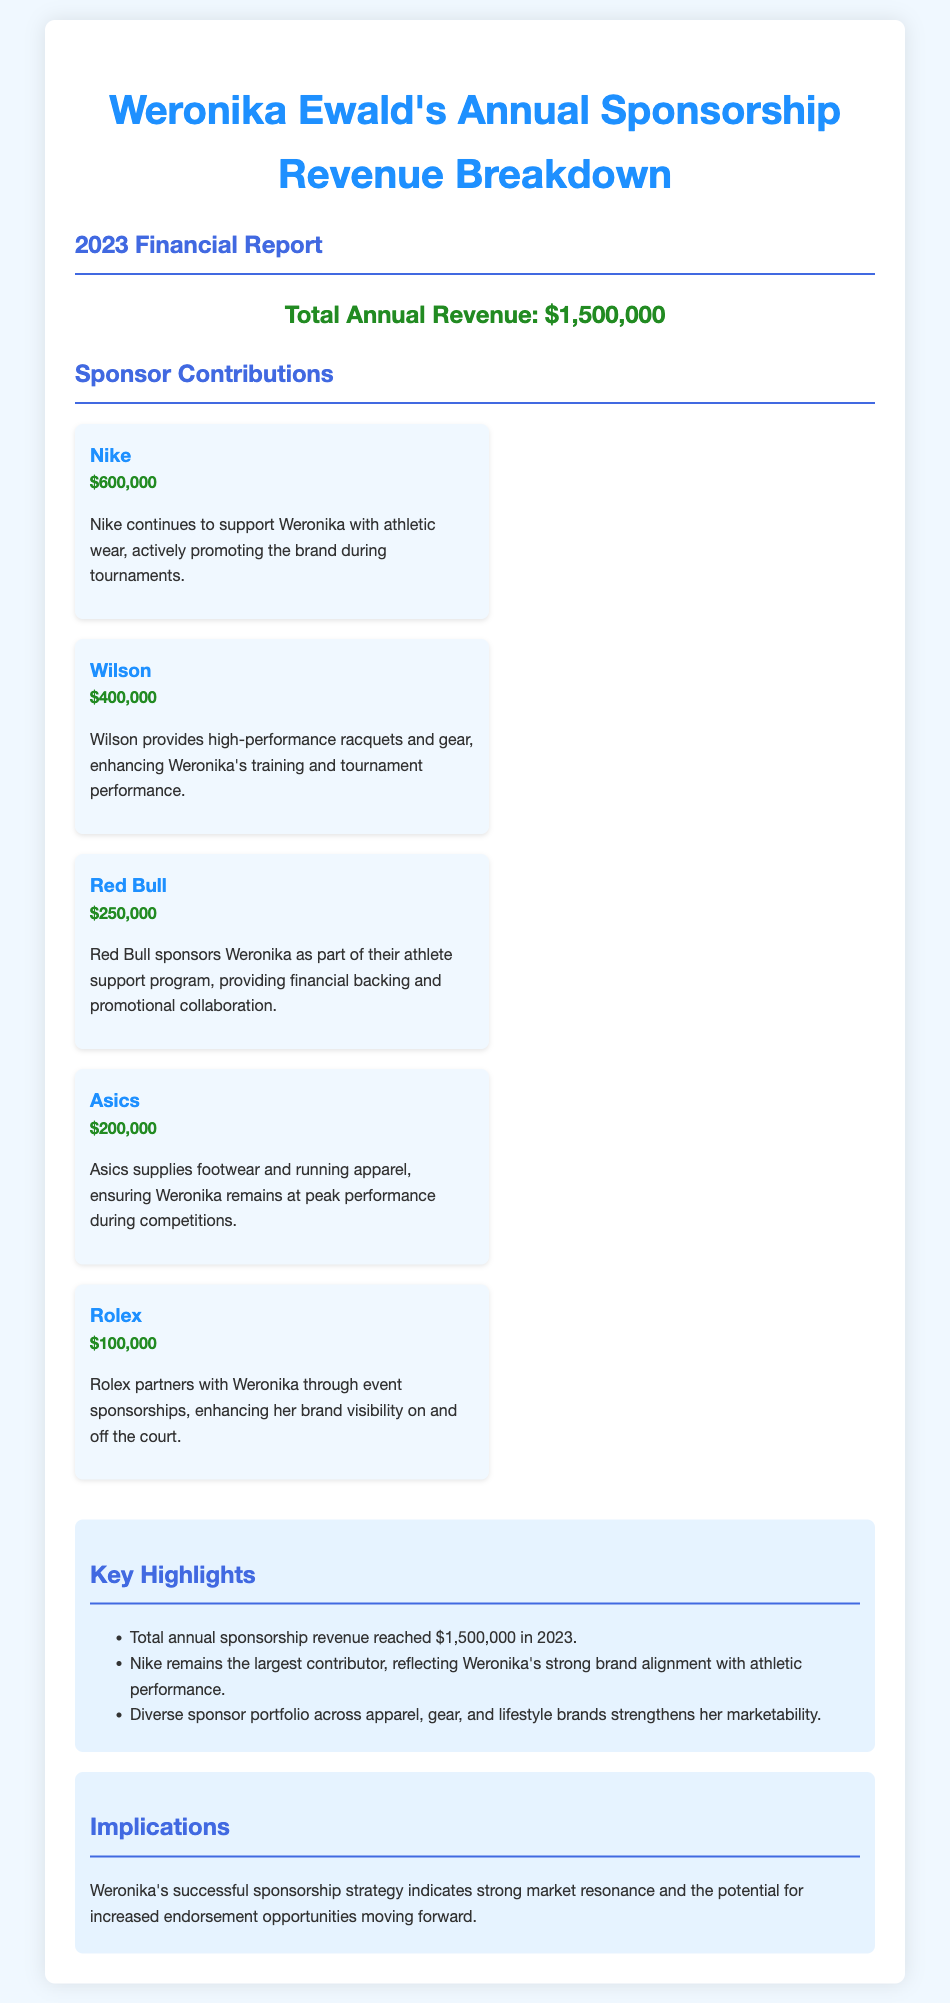What is the total annual revenue? The total annual revenue is stated in the document as $1,500,000.
Answer: $1,500,000 Who is the largest sponsor? The document highlights Nike as the largest contributor to Weronika's sponsorship revenue.
Answer: Nike How much does Wilson contribute? Wilson's contribution is specifically mentioned as $400,000 in the report.
Answer: $400,000 What type of products does Asics provide? The report indicates that Asics supplies footwear and running apparel to Weronika.
Answer: Footwear and running apparel What was the total contribution from Red Bull? The document specifies that Red Bull's sponsorship amount is $250,000.
Answer: $250,000 What key highlight is mentioned about Nike? The document states that Nike remains the largest contributor, indicating a strong brand alignment.
Answer: Largest contributor What does the sponsorship strategy indicate? The implications section of the document suggests a strong market resonance and potential for increased endorsement opportunities.
Answer: Strong market resonance What is Rolex's sponsorship type? The financial report describes Rolex's partnership with Weronika through event sponsorships.
Answer: Event sponsorships 